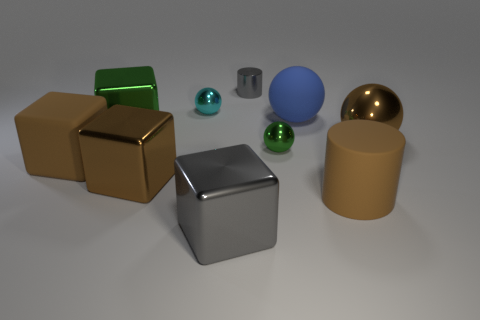There is a rubber object that is the same color as the matte cylinder; what is its shape?
Ensure brevity in your answer.  Cube. There is a shiny ball that is behind the brown ball that is in front of the blue matte ball; what number of big brown metallic blocks are right of it?
Offer a very short reply. 0. The large matte thing on the left side of the cylinder left of the brown cylinder is what color?
Keep it short and to the point. Brown. Is there a cyan metallic ball that has the same size as the brown metallic block?
Offer a terse response. No. There is a tiny object that is on the left side of the block right of the big brown metal object on the left side of the tiny green thing; what is it made of?
Provide a succinct answer. Metal. There is a cylinder that is behind the brown metal cube; what number of tiny gray metallic objects are to the right of it?
Ensure brevity in your answer.  0. Does the shiny sphere on the left side of the gray metallic cylinder have the same size as the matte cylinder?
Provide a short and direct response. No. How many cyan objects are the same shape as the small green object?
Make the answer very short. 1. What shape is the small gray metallic object?
Make the answer very short. Cylinder. Is the number of small cyan objects that are on the right side of the big brown matte cube the same as the number of green things?
Provide a succinct answer. No. 